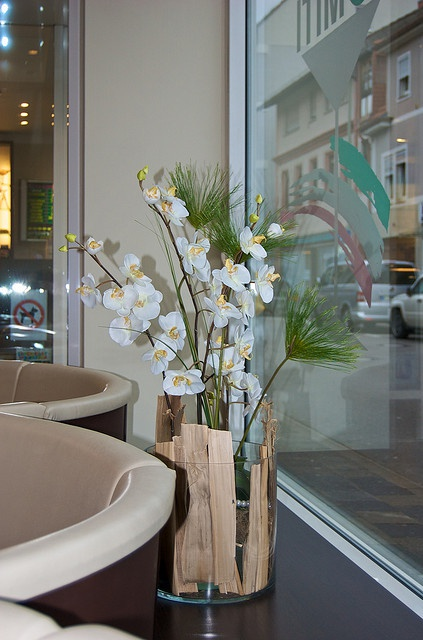Describe the objects in this image and their specific colors. I can see chair in gray, black, darkgray, and lightgray tones, vase in gray, black, and darkgray tones, chair in gray, darkgray, and black tones, car in gray, darkgray, and black tones, and car in gray, black, and darkgray tones in this image. 